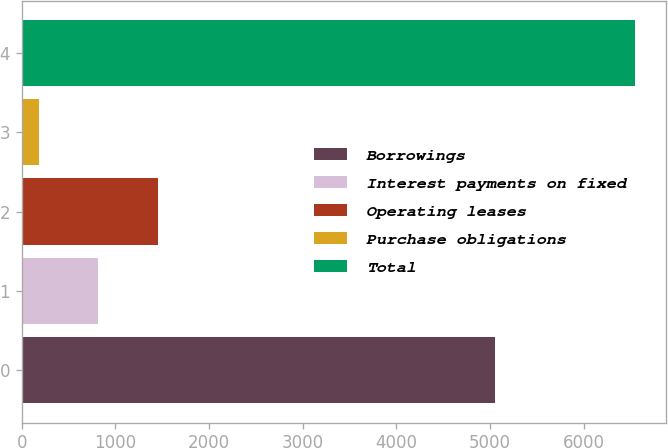<chart> <loc_0><loc_0><loc_500><loc_500><bar_chart><fcel>Borrowings<fcel>Interest payments on fixed<fcel>Operating leases<fcel>Purchase obligations<fcel>Total<nl><fcel>5057<fcel>817.72<fcel>1454.74<fcel>180.7<fcel>6550.9<nl></chart> 